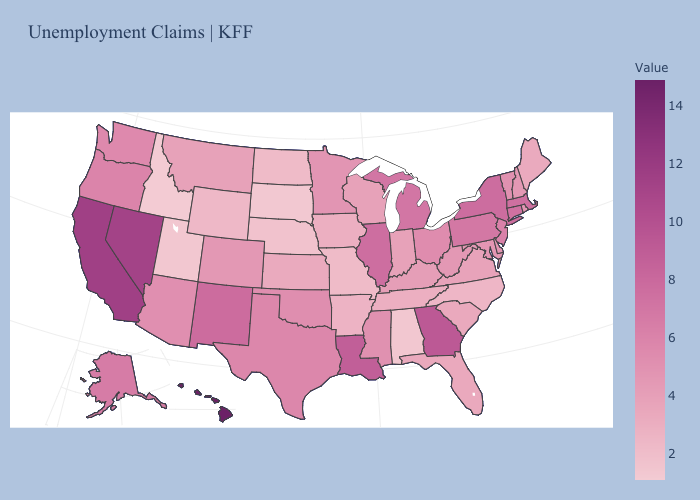Does Maine have the lowest value in the USA?
Be succinct. No. Which states hav the highest value in the Northeast?
Write a very short answer. New York. Is the legend a continuous bar?
Concise answer only. Yes. Which states hav the highest value in the South?
Concise answer only. Georgia. Does Colorado have the highest value in the West?
Write a very short answer. No. Which states hav the highest value in the West?
Short answer required. Hawaii. 